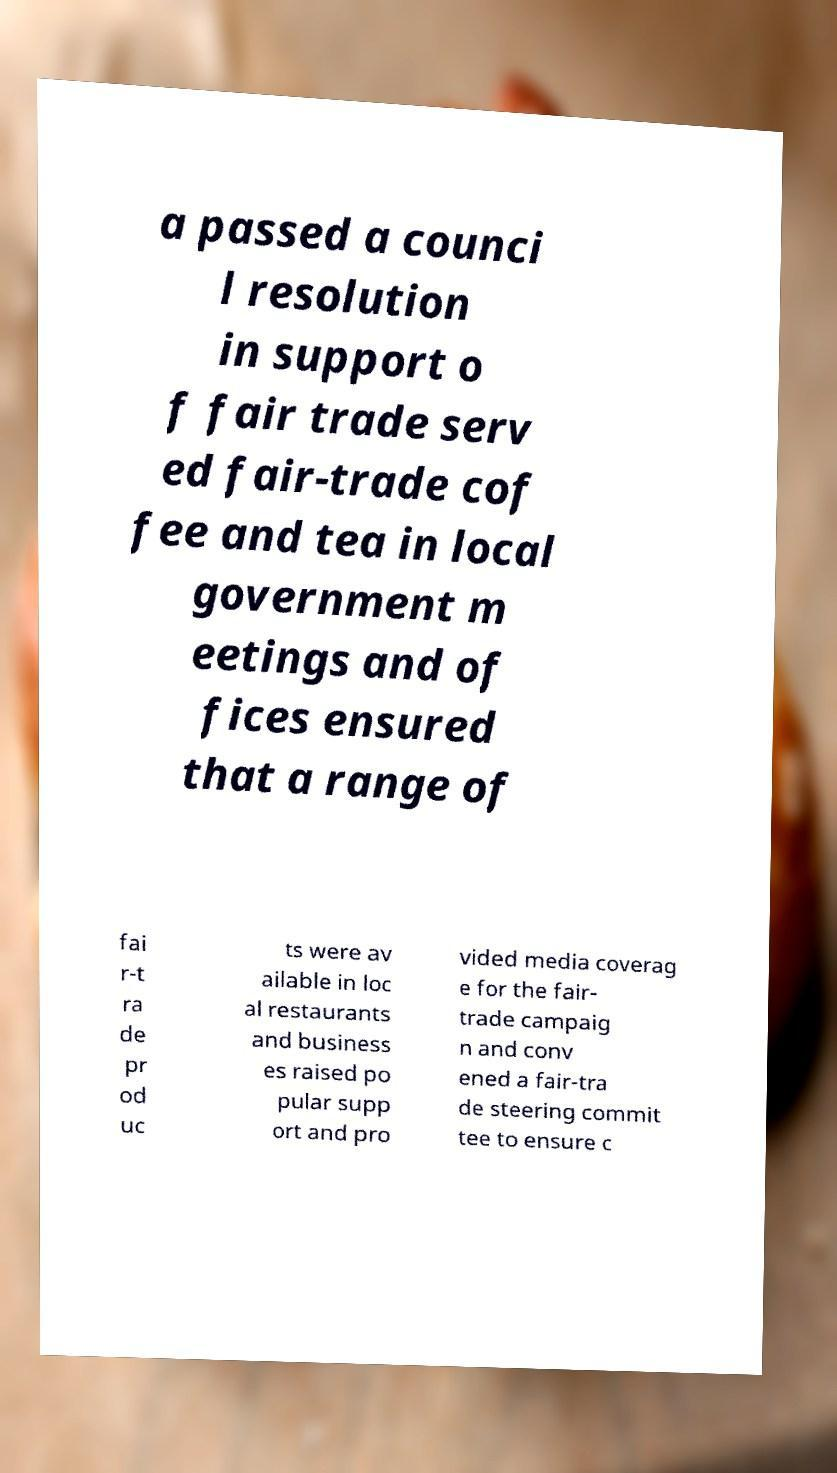Can you accurately transcribe the text from the provided image for me? a passed a counci l resolution in support o f fair trade serv ed fair-trade cof fee and tea in local government m eetings and of fices ensured that a range of fai r-t ra de pr od uc ts were av ailable in loc al restaurants and business es raised po pular supp ort and pro vided media coverag e for the fair- trade campaig n and conv ened a fair-tra de steering commit tee to ensure c 